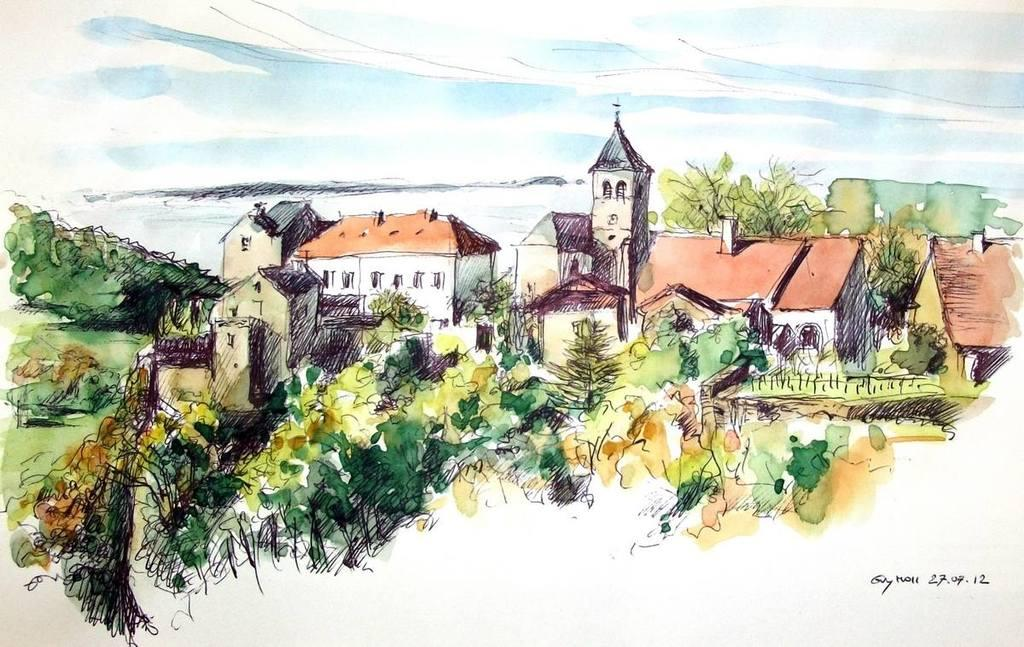What is the main subject of the image? The image contains a painting. What is being depicted in the painting? The painting depicts houses and trees. What type of chalk is being used to draw the houses in the painting? There is no chalk present in the image, as it is a painting and not a drawing. 